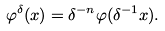<formula> <loc_0><loc_0><loc_500><loc_500>\varphi ^ { \delta } ( x ) = \delta ^ { - n } \varphi ( \delta ^ { - 1 } x ) .</formula> 